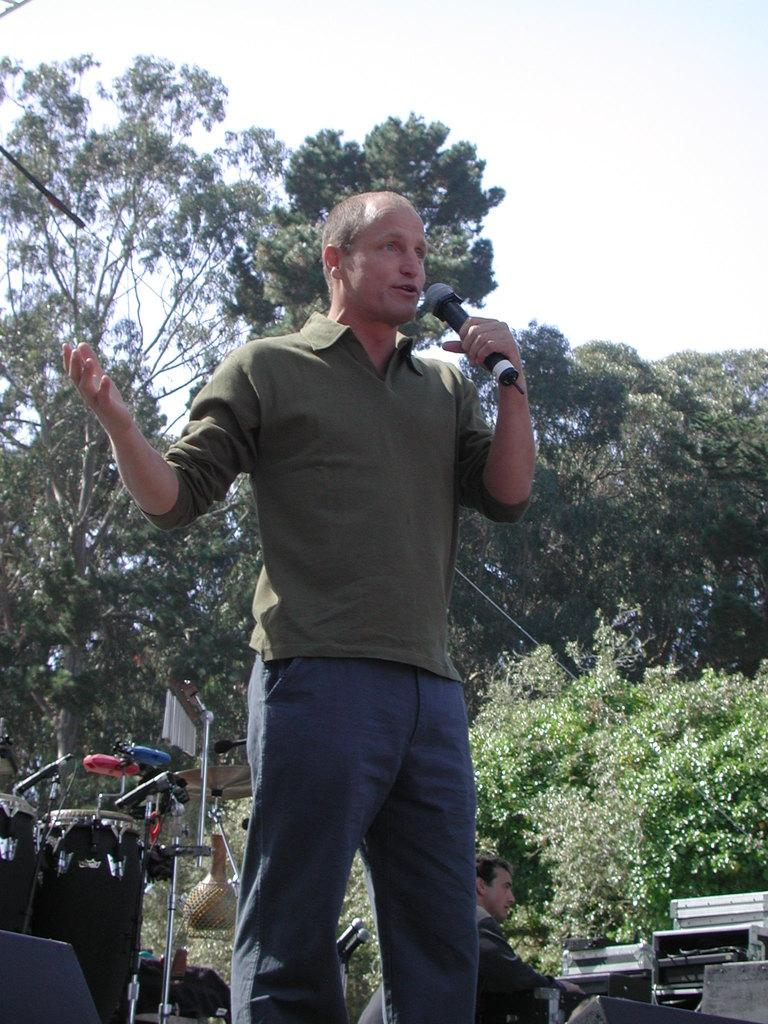What can be seen in the background of the image? There is a sky in the image. What type of natural elements are present in the image? There are trees in the image. What is the man in the image holding? The man is holding a microphone in the image. What type of yarn is the man using to decorate the trees in the image? There is no yarn present in the image, and the man is not decorating the trees. 